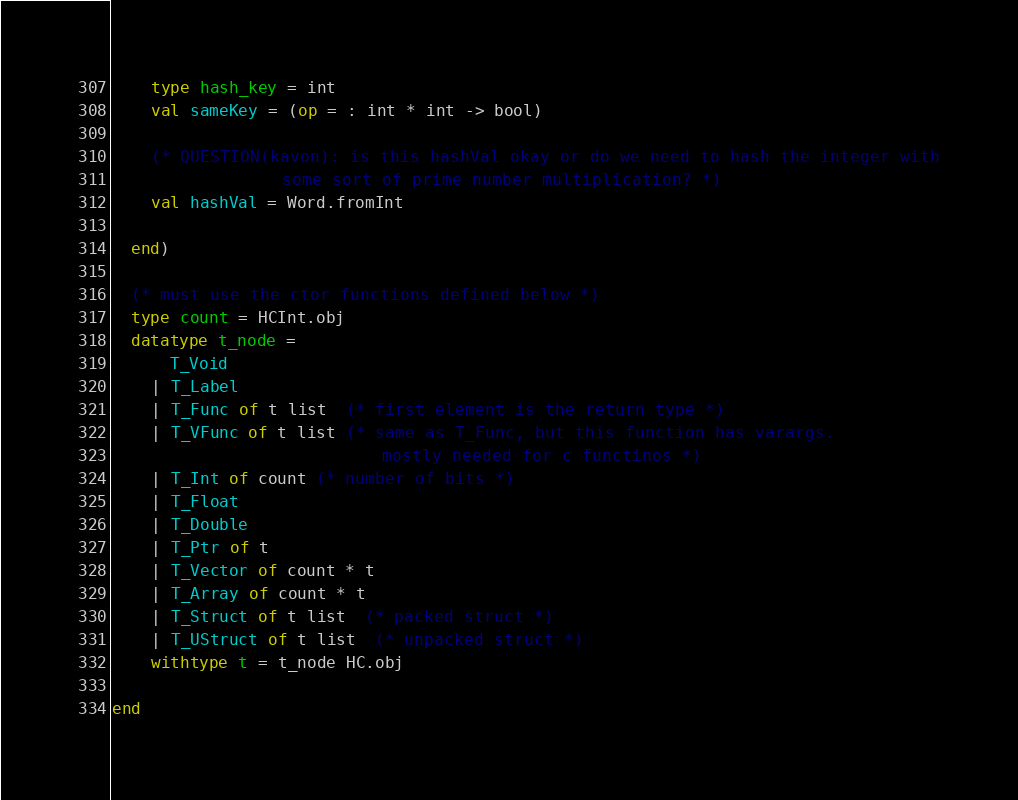Convert code to text. <code><loc_0><loc_0><loc_500><loc_500><_SML_>    type hash_key = int
    val sameKey = (op = : int * int -> bool)

    (* QUESTION(kavon): is this hashVal okay or do we need to hash the integer with
                 some sort of prime number multiplication? *)
    val hashVal = Word.fromInt 

  end)

  (* must use the ctor functions defined below *)
  type count = HCInt.obj
  datatype t_node = 
      T_Void
    | T_Label
    | T_Func of t list  (* first element is the return type *)
    | T_VFunc of t list (* same as T_Func, but this function has varargs. 
                           mostly needed for c functinos *)
    | T_Int of count (* number of bits *)
    | T_Float
    | T_Double
    | T_Ptr of t
    | T_Vector of count * t
    | T_Array of count * t
    | T_Struct of t list  (* packed struct *)
    | T_UStruct of t list  (* unpacked struct *)
    withtype t = t_node HC.obj  
  
end
</code> 